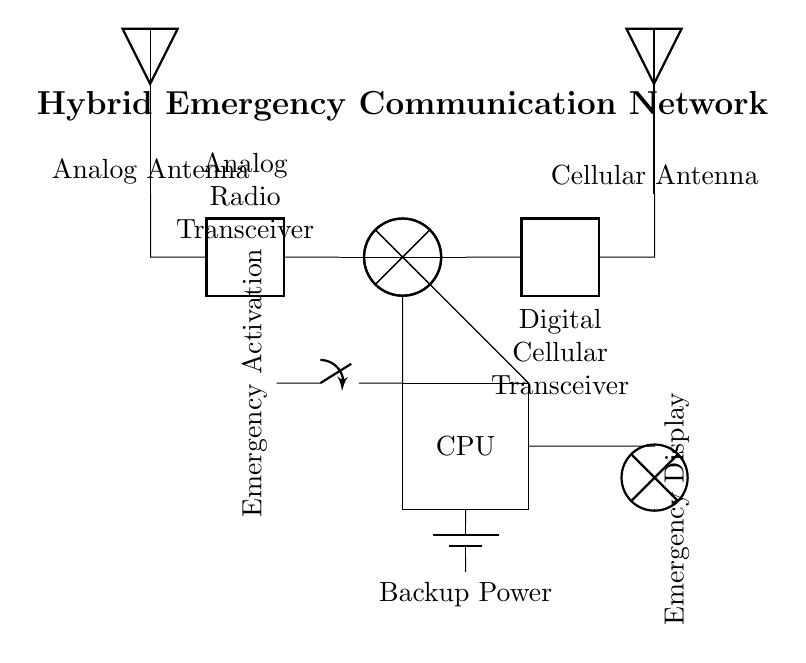What are the two types of transceivers in the circuit? The circuit shows an Analog Radio Transceiver and a Digital Cellular Transceiver, as indicated by their labels.
Answer: Analog Radio Transceiver, Digital Cellular Transceiver What is the role of the CPU in this circuit? The Central Processing Unit is responsible for processing signals from both the analog and digital systems, coordinating their operations, as it is directly connected to each transceiver's mixer.
Answer: Processing signals What is the purpose of the emergency switch? The emergency switch is used to activate the emergency communication system, allowing for an immediate response in case of an emergency, as noted by its label and position in the circuit.
Answer: Emergency activation What type of power supply is indicated in the circuit? The circuit has a backup battery power supply, which is depicted at the bottom, ensuring the system remains operational during power failure.
Answer: Backup power How many antennas are present in the hybrid emergency communication network? There are two antennas in the circuit, one for the analog system and another for the digital cellular system, both labeled accordingly.
Answer: Two antennas Which component receives signals from both the analog and digital systems? The CPU receives signals from both systems, as it is connected to the mixers of the analog and digital transceivers.
Answer: CPU What displays the emergency status in the circuit? The emergency display is represented by a lamp, which is connected to the output of the digital transceiver through the CPU, indicating the system status.
Answer: Emergency display 